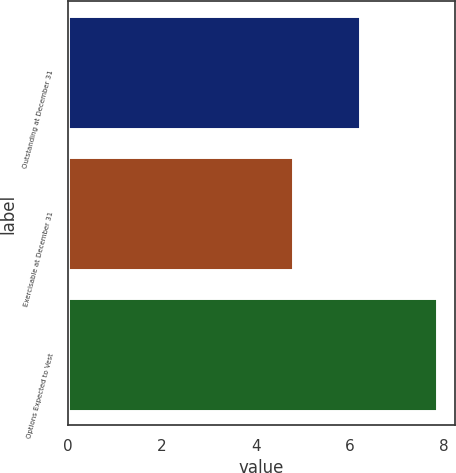Convert chart to OTSL. <chart><loc_0><loc_0><loc_500><loc_500><bar_chart><fcel>Outstanding at December 31<fcel>Exercisable at December 31<fcel>Options Expected to Vest<nl><fcel>6.23<fcel>4.79<fcel>7.85<nl></chart> 